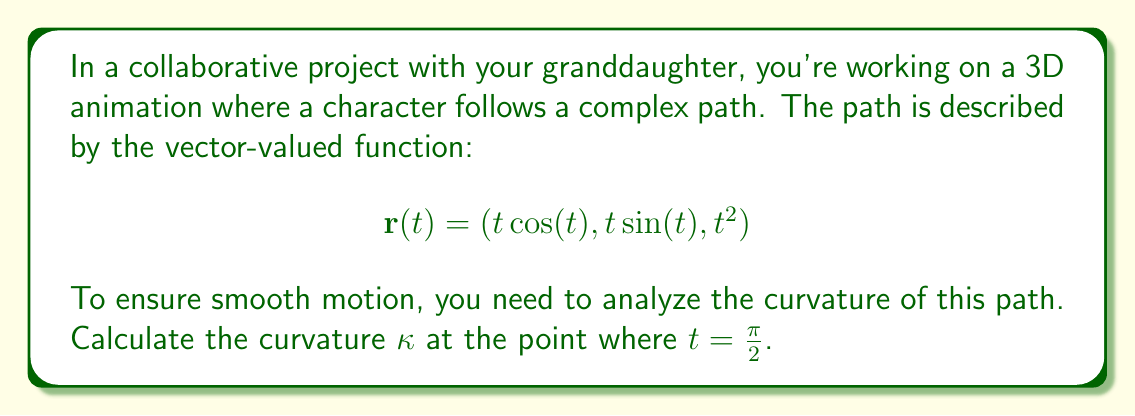Can you answer this question? To find the curvature of a 3D path, we use the formula:

$$\kappa = \frac{|\mathbf{r}'(t) \times \mathbf{r}''(t)|}{|\mathbf{r}'(t)|^3}$$

Let's break this down step-by-step:

1) First, we need to find $\mathbf{r}'(t)$ and $\mathbf{r}''(t)$:

   $\mathbf{r}'(t) = (\cos(t) - t\sin(t), \sin(t) + t\cos(t), 2t)$
   $\mathbf{r}''(t) = (-2\sin(t) - t\cos(t), 2\cos(t) - t\sin(t), 2)$

2) Now, let's evaluate these at $t = \frac{\pi}{2}$:

   $\mathbf{r}'(\frac{\pi}{2}) = (-\frac{\pi}{2}, 1, \pi)$
   $\mathbf{r}''(\frac{\pi}{2}) = (-1, -\frac{\pi}{2}, 2)$

3) Next, we need to calculate the cross product $\mathbf{r}'(\frac{\pi}{2}) \times \mathbf{r}''(\frac{\pi}{2})$:

   $$\begin{vmatrix} 
   \mathbf{i} & \mathbf{j} & \mathbf{k} \\
   -\frac{\pi}{2} & 1 & \pi \\
   -1 & -\frac{\pi}{2} & 2
   \end{vmatrix} = (-\frac{\pi^2}{2} - 2)\mathbf{i} + (\pi - \frac{\pi}{2})\mathbf{j} + (\frac{\pi^2}{4} + 1)\mathbf{k}$$

4) The magnitude of this cross product is:

   $|\mathbf{r}'(\frac{\pi}{2}) \times \mathbf{r}''(\frac{\pi}{2})| = \sqrt{(-\frac{\pi^2}{2} - 2)^2 + (\frac{\pi}{2})^2 + (\frac{\pi^2}{4} + 1)^2}$

5) We also need $|\mathbf{r}'(\frac{\pi}{2})|^3$:

   $|\mathbf{r}'(\frac{\pi}{2})| = \sqrt{(\frac{\pi}{2})^2 + 1^2 + \pi^2} = \sqrt{\frac{5\pi^2}{4} + 1}$

   $|\mathbf{r}'(\frac{\pi}{2})|^3 = (\frac{5\pi^2}{4} + 1)^{3/2}$

6) Finally, we can calculate the curvature:

   $$\kappa = \frac{\sqrt{(-\frac{\pi^2}{2} - 2)^2 + (\frac{\pi}{2})^2 + (\frac{\pi^2}{4} + 1)^2}}{(\frac{5\pi^2}{4} + 1)^{3/2}}$$
Answer: The curvature at $t = \frac{\pi}{2}$ is:

$$\kappa = \frac{\sqrt{(-\frac{\pi^2}{2} - 2)^2 + (\frac{\pi}{2})^2 + (\frac{\pi^2}{4} + 1)^2}}{(\frac{5\pi^2}{4} + 1)^{3/2}}$$ 